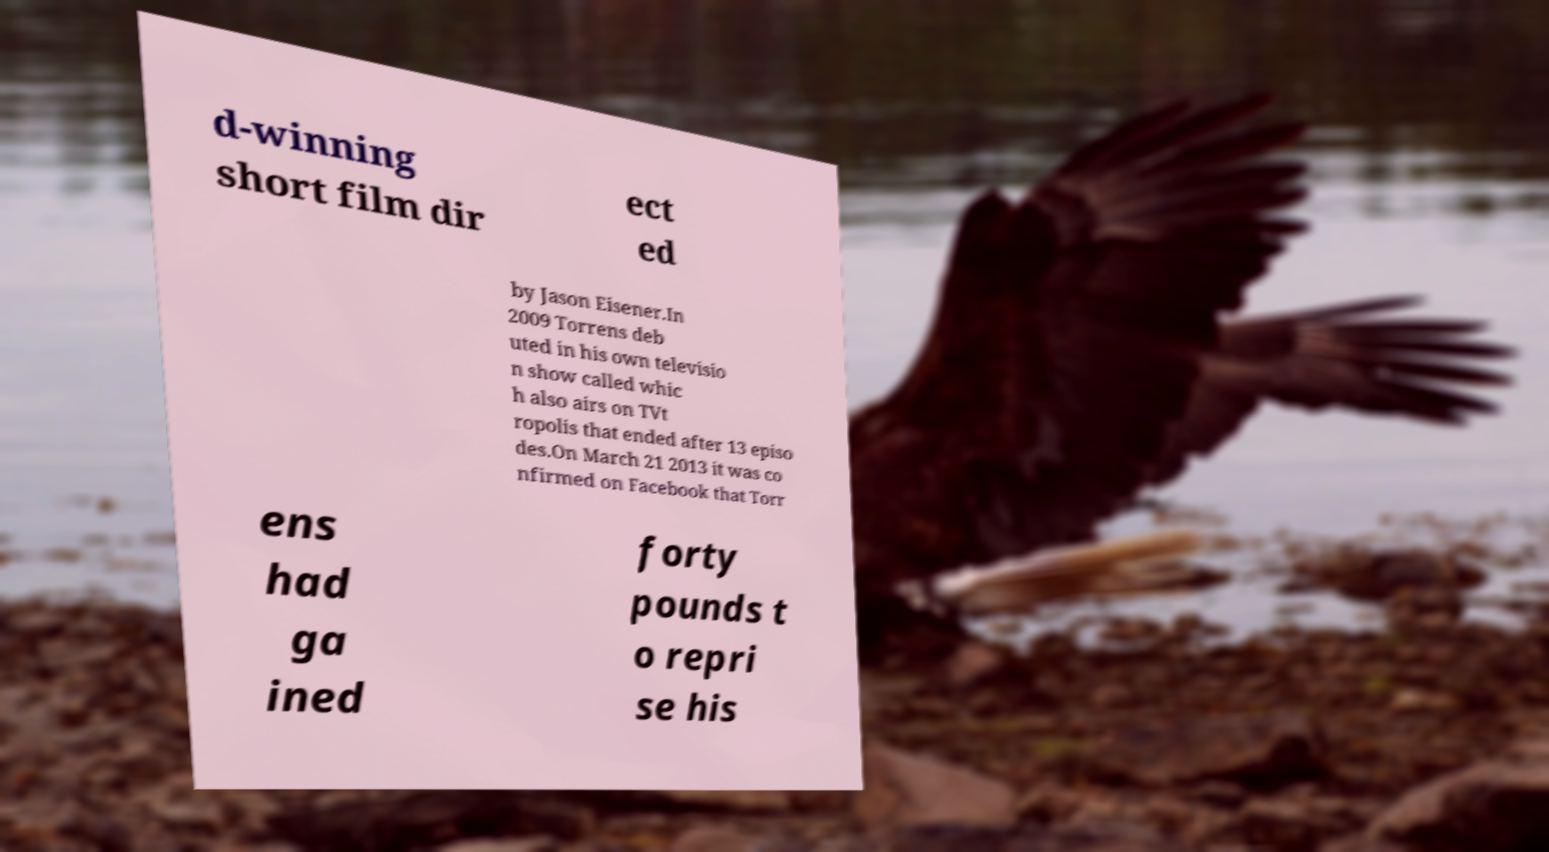Can you accurately transcribe the text from the provided image for me? d-winning short film dir ect ed by Jason Eisener.In 2009 Torrens deb uted in his own televisio n show called whic h also airs on TVt ropolis that ended after 13 episo des.On March 21 2013 it was co nfirmed on Facebook that Torr ens had ga ined forty pounds t o repri se his 